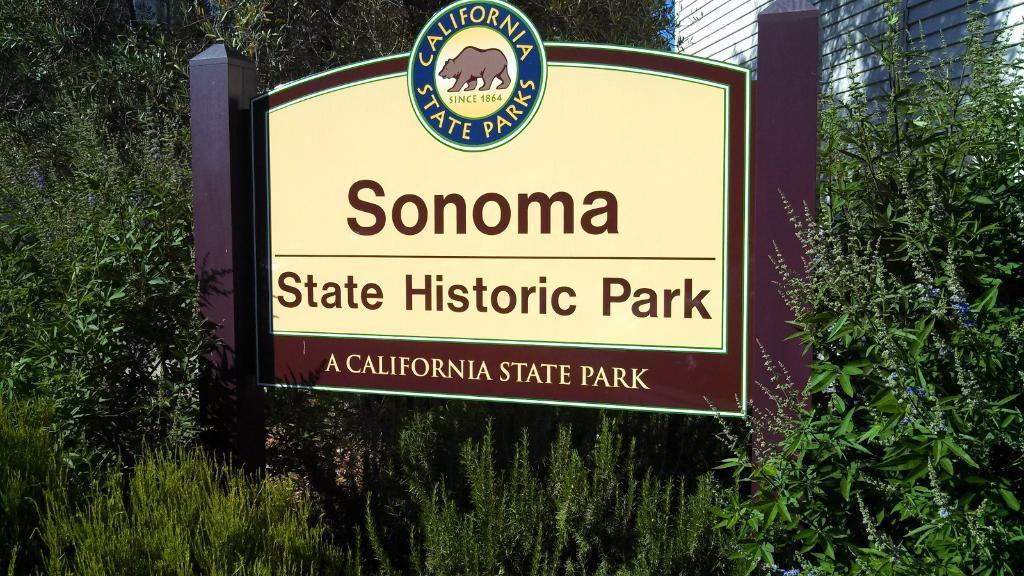How would you summarize this image in a sentence or two? In this picture we can see a board with poles and behind the board there are trees, wall and a sky. 